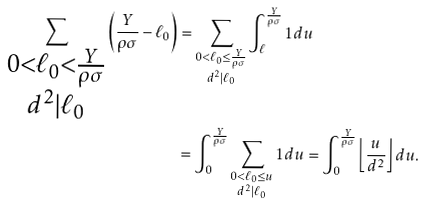<formula> <loc_0><loc_0><loc_500><loc_500>\sum _ { \substack { 0 < \ell _ { 0 } < \frac { Y } { \rho \sigma } \\ d ^ { 2 } | \ell _ { 0 } } } \left ( \frac { Y } { \rho \sigma } - \ell _ { 0 } \right ) & = \sum _ { \substack { 0 < \ell _ { 0 } \leq \frac { Y } { \rho \sigma } \\ d ^ { 2 } | \ell _ { 0 } } } \int _ { \ell } ^ { \frac { Y } { \rho \sigma } } 1 d u \\ & = \int _ { 0 } ^ { \frac { Y } { \rho \sigma } } \sum _ { \substack { 0 < \ell _ { 0 } \leq u \\ d ^ { 2 } | \ell _ { 0 } } } 1 d u = \int _ { 0 } ^ { \frac { Y } { \rho \sigma } } \left \lfloor \frac { u } { d ^ { 2 } } \right \rfloor d u .</formula> 